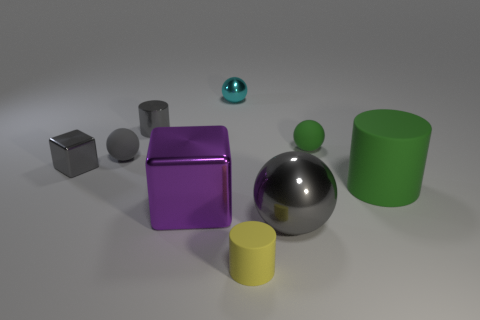There is a tiny cylinder behind the small green object; what is its color?
Offer a terse response. Gray. There is a small cylinder that is on the right side of the purple thing; is there a cyan sphere that is in front of it?
Give a very brief answer. No. There is a large rubber thing; is it the same color as the rubber sphere right of the large purple metallic thing?
Your response must be concise. Yes. Is there a big gray sphere made of the same material as the tiny green thing?
Ensure brevity in your answer.  No. How many green things are there?
Ensure brevity in your answer.  2. What is the gray ball that is in front of the cylinder right of the small yellow rubber cylinder made of?
Give a very brief answer. Metal. There is another ball that is the same material as the green ball; what color is it?
Provide a succinct answer. Gray. What is the shape of the matte object that is the same color as the big sphere?
Keep it short and to the point. Sphere. Do the metallic cube behind the large matte object and the matte sphere that is left of the small green object have the same size?
Give a very brief answer. Yes. How many blocks are metallic objects or yellow matte objects?
Ensure brevity in your answer.  2. 